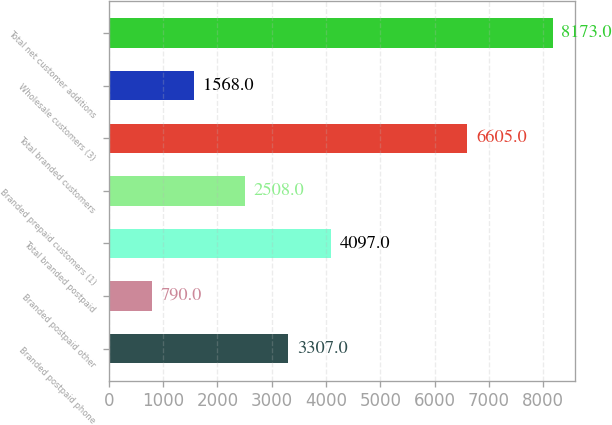Convert chart. <chart><loc_0><loc_0><loc_500><loc_500><bar_chart><fcel>Branded postpaid phone<fcel>Branded postpaid other<fcel>Total branded postpaid<fcel>Branded prepaid customers (1)<fcel>Total branded customers<fcel>Wholesale customers (3)<fcel>Total net customer additions<nl><fcel>3307<fcel>790<fcel>4097<fcel>2508<fcel>6605<fcel>1568<fcel>8173<nl></chart> 